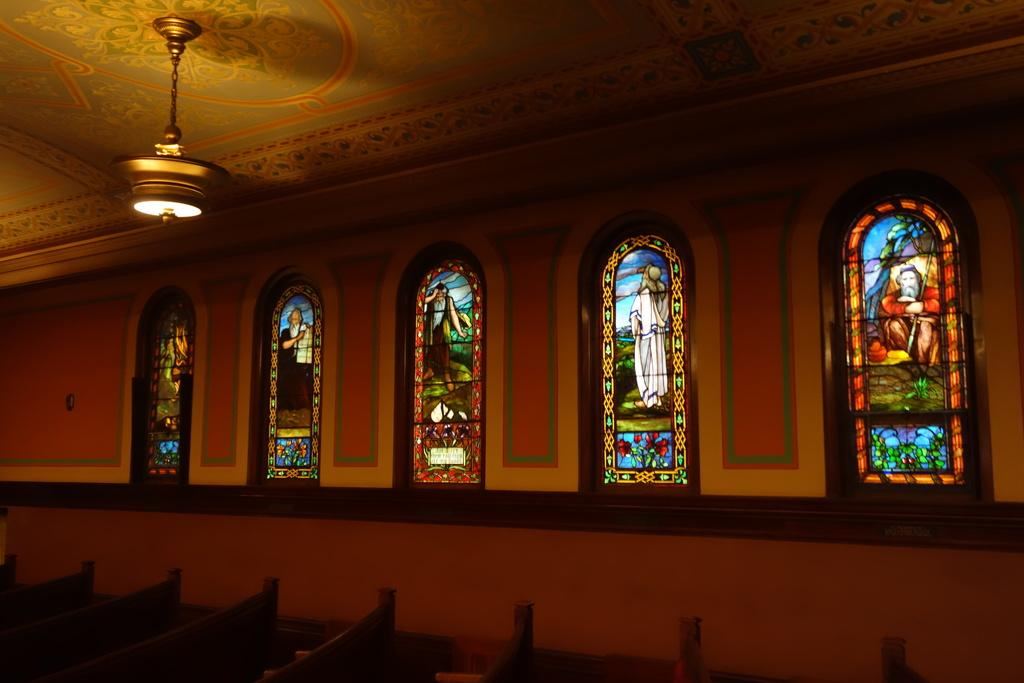Where was the image taken? The image was taken in a church. What type of glasses can be seen in the image? The glasses in the image have pictures in the center. What type of seating is available in the image? There are benches at the bottom of the image. What is visible at the top of the image? Light is visible at the top of the image. What type of window can be seen in the image? There is no window visible in the image. 